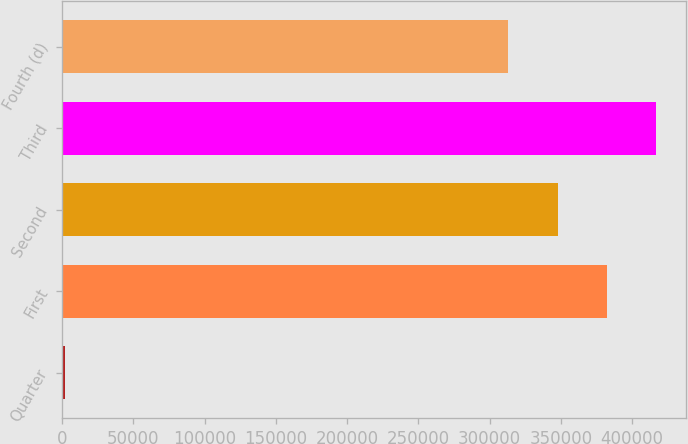Convert chart to OTSL. <chart><loc_0><loc_0><loc_500><loc_500><bar_chart><fcel>Quarter<fcel>First<fcel>Second<fcel>Third<fcel>Fourth (d)<nl><fcel>2015<fcel>382178<fcel>347667<fcel>416689<fcel>313156<nl></chart> 